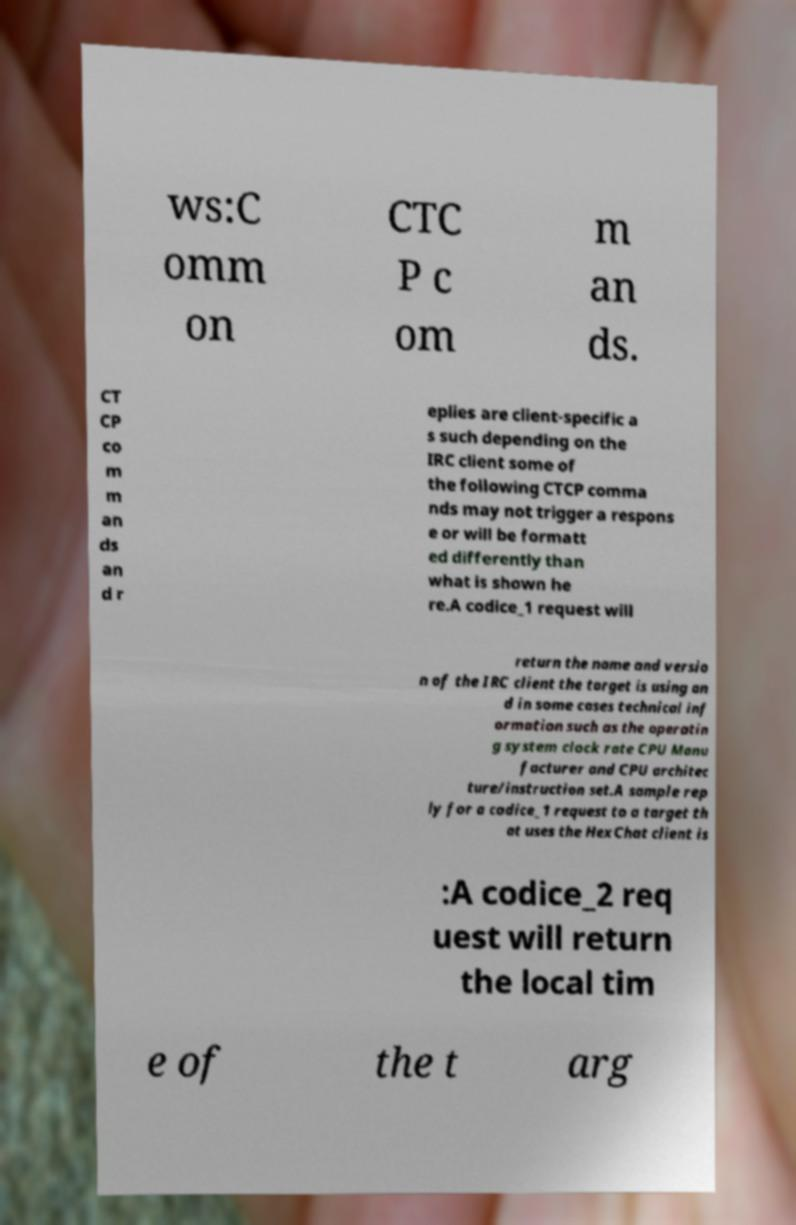Can you read and provide the text displayed in the image?This photo seems to have some interesting text. Can you extract and type it out for me? ws:C omm on CTC P c om m an ds. CT CP co m m an ds an d r eplies are client-specific a s such depending on the IRC client some of the following CTCP comma nds may not trigger a respons e or will be formatt ed differently than what is shown he re.A codice_1 request will return the name and versio n of the IRC client the target is using an d in some cases technical inf ormation such as the operatin g system clock rate CPU Manu facturer and CPU architec ture/instruction set.A sample rep ly for a codice_1 request to a target th at uses the HexChat client is :A codice_2 req uest will return the local tim e of the t arg 